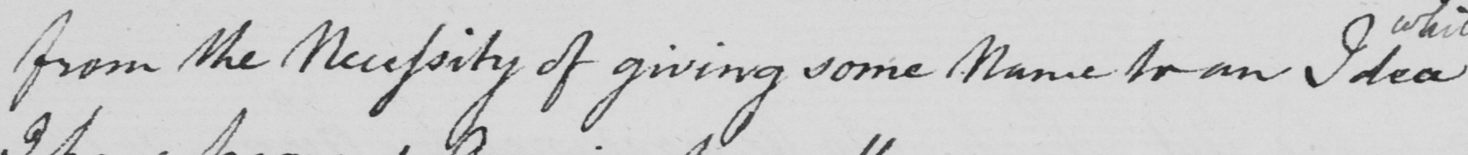Can you tell me what this handwritten text says? from the Necessity of giving some Name for an Idea 